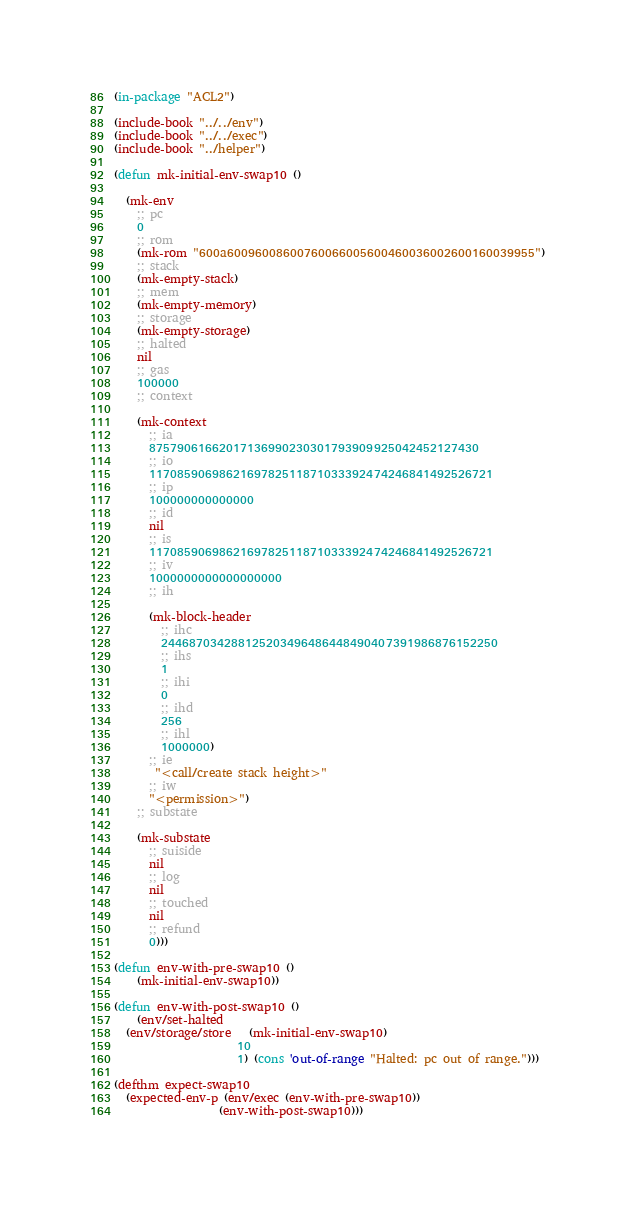<code> <loc_0><loc_0><loc_500><loc_500><_Lisp_>
(in-package "ACL2")

(include-book "../../env")
(include-book "../../exec")
(include-book "../helper")

(defun mk-initial-env-swap10 ()

  (mk-env
    ;; pc
    0
    ;; rom
    (mk-rom "600a60096008600760066005600460036002600160039955")
    ;; stack
    (mk-empty-stack)
    ;; mem
    (mk-empty-memory)
    ;; storage
    (mk-empty-storage)
    ;; halted
    nil
    ;; gas
    100000
    ;; context
  
    (mk-context
      ;; ia
      87579061662017136990230301793909925042452127430
      ;; io
      1170859069862169782511871033392474246841492526721
      ;; ip
      100000000000000
      ;; id
      nil
      ;; is
      1170859069862169782511871033392474246841492526721
      ;; iv
      1000000000000000000
      ;; ih
  
      (mk-block-header
        ;; ihc
        244687034288125203496486448490407391986876152250
        ;; ihs
        1
        ;; ihi
        0
        ;; ihd
        256
        ;; ihl
        1000000)
      ;; ie
       "<call/create stack height>"
      ;; iw
      "<permission>")
    ;; substate
  
    (mk-substate
      ;; suiside
      nil
      ;; log
      nil
      ;; touched
      nil
      ;; refund
      0)))

(defun env-with-pre-swap10 ()
    (mk-initial-env-swap10))

(defun env-with-post-swap10 ()
    (env/set-halted 
  (env/storage/store   (mk-initial-env-swap10)
                     10
                     1) (cons 'out-of-range "Halted: pc out of range.")))

(defthm expect-swap10
  (expected-env-p (env/exec (env-with-pre-swap10))
                  (env-with-post-swap10)))</code> 